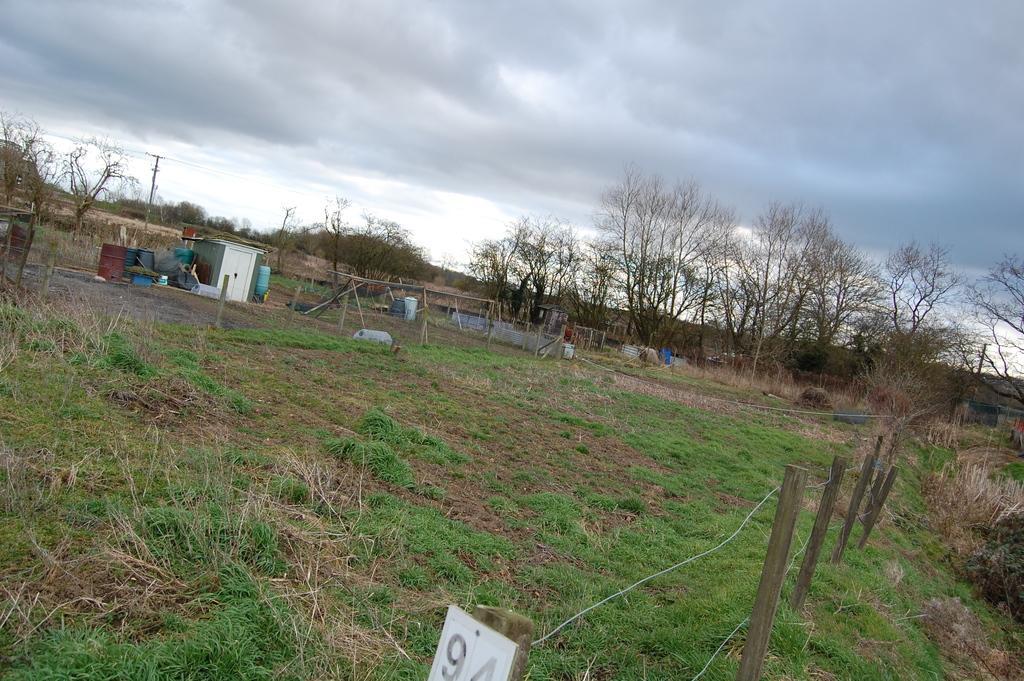Can you describe this image briefly? At the bottom of the picture, we see a white board with numbers written on it. Beside that, we see the grass and we even see the wooden fence. In the middle of the picture, we see wooden sticks, a white shed and drums. There are trees and electric poles in the background. At the top, we see the sky. 